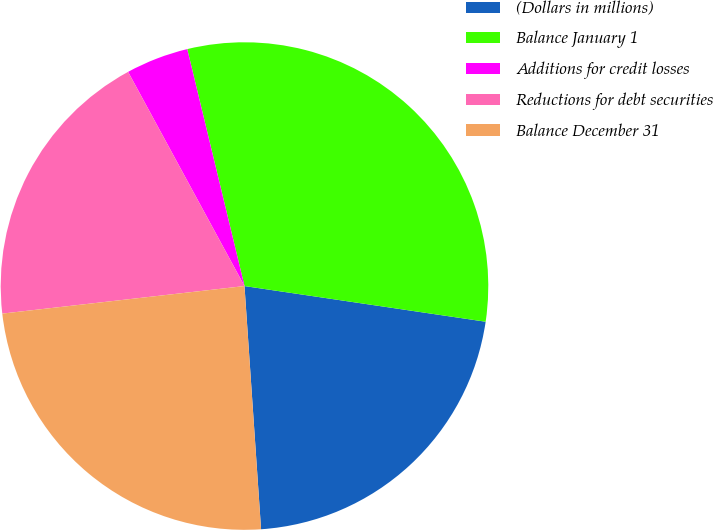Convert chart. <chart><loc_0><loc_0><loc_500><loc_500><pie_chart><fcel>(Dollars in millions)<fcel>Balance January 1<fcel>Additions for credit losses<fcel>Reductions for debt securities<fcel>Balance December 31<nl><fcel>21.58%<fcel>31.11%<fcel>4.15%<fcel>18.88%<fcel>24.28%<nl></chart> 